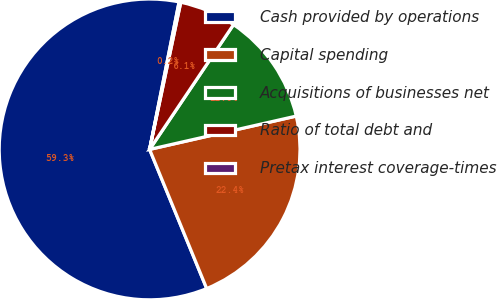Convert chart. <chart><loc_0><loc_0><loc_500><loc_500><pie_chart><fcel>Cash provided by operations<fcel>Capital spending<fcel>Acquisitions of businesses net<fcel>Ratio of total debt and<fcel>Pretax interest coverage-times<nl><fcel>59.34%<fcel>22.36%<fcel>12.02%<fcel>6.1%<fcel>0.18%<nl></chart> 